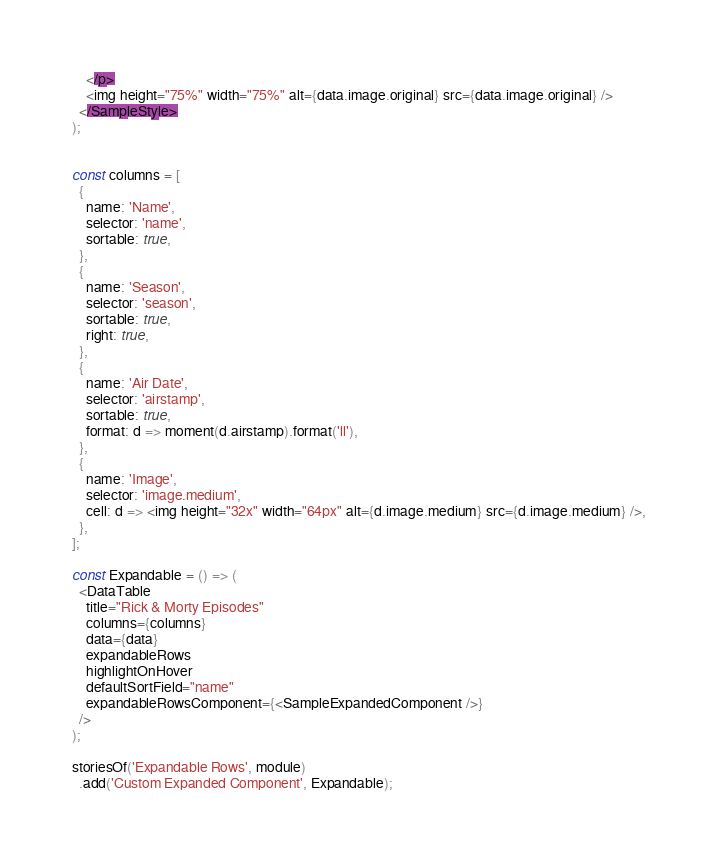Convert code to text. <code><loc_0><loc_0><loc_500><loc_500><_JavaScript_>    </p>
    <img height="75%" width="75%" alt={data.image.original} src={data.image.original} />
  </SampleStyle>
);


const columns = [
  {
    name: 'Name',
    selector: 'name',
    sortable: true,
  },
  {
    name: 'Season',
    selector: 'season',
    sortable: true,
    right: true,
  },
  {
    name: 'Air Date',
    selector: 'airstamp',
    sortable: true,
    format: d => moment(d.airstamp).format('ll'),
  },
  {
    name: 'Image',
    selector: 'image.medium',
    cell: d => <img height="32x" width="64px" alt={d.image.medium} src={d.image.medium} />,
  },
];

const Expandable = () => (
  <DataTable
    title="Rick & Morty Episodes"
    columns={columns}
    data={data}
    expandableRows
    highlightOnHover
    defaultSortField="name"
    expandableRowsComponent={<SampleExpandedComponent />}
  />
);

storiesOf('Expandable Rows', module)
  .add('Custom Expanded Component', Expandable);
</code> 